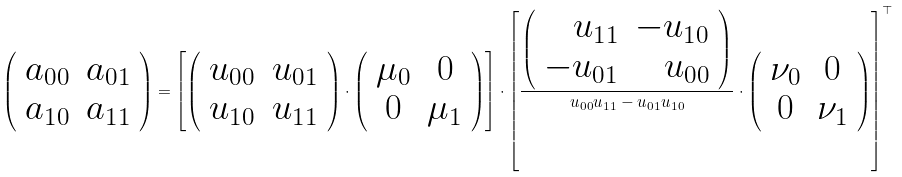<formula> <loc_0><loc_0><loc_500><loc_500>\left ( \begin{array} { c c } a _ { 0 0 } & a _ { 0 1 } \\ a _ { 1 0 } & a _ { 1 1 } \end{array} \right ) = \left [ \left ( \begin{array} { c c } u _ { 0 0 } & u _ { 0 1 } \\ u _ { 1 0 } & u _ { 1 1 } \end{array} \right ) \cdot \left ( \begin{array} { c c } \mu _ { 0 } & 0 \\ 0 & \mu _ { 1 } \end{array} \right ) \right ] \cdot \left [ \frac { \left ( \begin{array} { r r } u _ { 1 1 } & - u _ { 1 0 } \\ - u _ { 0 1 } & u _ { 0 0 } \end{array} \right ) } { u _ { 0 0 } u _ { 1 1 } - u _ { 0 1 } u _ { 1 0 } } \cdot \left ( \begin{array} { c c } \nu _ { 0 } & 0 \\ 0 & \nu _ { 1 } \end{array} \right ) \right ] ^ { \top }</formula> 